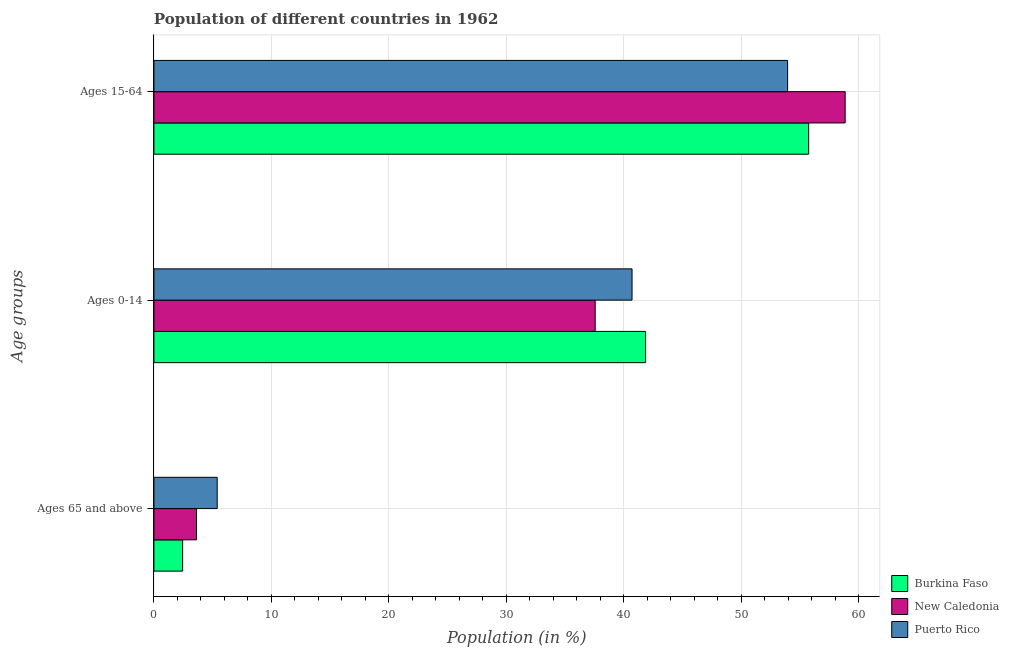How many bars are there on the 2nd tick from the top?
Offer a very short reply. 3. What is the label of the 1st group of bars from the top?
Make the answer very short. Ages 15-64. What is the percentage of population within the age-group 0-14 in New Caledonia?
Give a very brief answer. 37.55. Across all countries, what is the maximum percentage of population within the age-group 15-64?
Offer a terse response. 58.82. Across all countries, what is the minimum percentage of population within the age-group 15-64?
Give a very brief answer. 53.93. In which country was the percentage of population within the age-group 0-14 maximum?
Your response must be concise. Burkina Faso. In which country was the percentage of population within the age-group of 65 and above minimum?
Offer a terse response. Burkina Faso. What is the total percentage of population within the age-group 15-64 in the graph?
Offer a very short reply. 168.47. What is the difference between the percentage of population within the age-group 15-64 in Burkina Faso and that in New Caledonia?
Keep it short and to the point. -3.11. What is the difference between the percentage of population within the age-group 0-14 in Burkina Faso and the percentage of population within the age-group of 65 and above in Puerto Rico?
Your answer should be very brief. 36.45. What is the average percentage of population within the age-group 15-64 per country?
Give a very brief answer. 56.16. What is the difference between the percentage of population within the age-group 15-64 and percentage of population within the age-group of 65 and above in New Caledonia?
Your response must be concise. 55.2. What is the ratio of the percentage of population within the age-group of 65 and above in Puerto Rico to that in New Caledonia?
Offer a terse response. 1.49. What is the difference between the highest and the second highest percentage of population within the age-group of 65 and above?
Provide a succinct answer. 1.76. What is the difference between the highest and the lowest percentage of population within the age-group of 65 and above?
Offer a terse response. 2.94. What does the 1st bar from the top in Ages 65 and above represents?
Offer a very short reply. Puerto Rico. What does the 2nd bar from the bottom in Ages 65 and above represents?
Your answer should be very brief. New Caledonia. Is it the case that in every country, the sum of the percentage of population within the age-group of 65 and above and percentage of population within the age-group 0-14 is greater than the percentage of population within the age-group 15-64?
Offer a very short reply. No. How many countries are there in the graph?
Provide a succinct answer. 3. How many legend labels are there?
Offer a very short reply. 3. How are the legend labels stacked?
Offer a very short reply. Vertical. What is the title of the graph?
Offer a terse response. Population of different countries in 1962. What is the label or title of the Y-axis?
Provide a short and direct response. Age groups. What is the Population (in %) of Burkina Faso in Ages 65 and above?
Make the answer very short. 2.44. What is the Population (in %) in New Caledonia in Ages 65 and above?
Make the answer very short. 3.63. What is the Population (in %) of Puerto Rico in Ages 65 and above?
Provide a succinct answer. 5.39. What is the Population (in %) of Burkina Faso in Ages 0-14?
Ensure brevity in your answer.  41.84. What is the Population (in %) of New Caledonia in Ages 0-14?
Offer a very short reply. 37.55. What is the Population (in %) of Puerto Rico in Ages 0-14?
Give a very brief answer. 40.69. What is the Population (in %) of Burkina Faso in Ages 15-64?
Provide a short and direct response. 55.72. What is the Population (in %) of New Caledonia in Ages 15-64?
Your answer should be compact. 58.82. What is the Population (in %) of Puerto Rico in Ages 15-64?
Your answer should be very brief. 53.93. Across all Age groups, what is the maximum Population (in %) of Burkina Faso?
Keep it short and to the point. 55.72. Across all Age groups, what is the maximum Population (in %) in New Caledonia?
Your answer should be compact. 58.82. Across all Age groups, what is the maximum Population (in %) in Puerto Rico?
Make the answer very short. 53.93. Across all Age groups, what is the minimum Population (in %) of Burkina Faso?
Provide a succinct answer. 2.44. Across all Age groups, what is the minimum Population (in %) in New Caledonia?
Keep it short and to the point. 3.63. Across all Age groups, what is the minimum Population (in %) of Puerto Rico?
Offer a terse response. 5.39. What is the total Population (in %) of Burkina Faso in the graph?
Provide a succinct answer. 100. What is the total Population (in %) of Puerto Rico in the graph?
Your answer should be compact. 100. What is the difference between the Population (in %) in Burkina Faso in Ages 65 and above and that in Ages 0-14?
Provide a short and direct response. -39.39. What is the difference between the Population (in %) in New Caledonia in Ages 65 and above and that in Ages 0-14?
Offer a terse response. -33.93. What is the difference between the Population (in %) in Puerto Rico in Ages 65 and above and that in Ages 0-14?
Give a very brief answer. -35.3. What is the difference between the Population (in %) in Burkina Faso in Ages 65 and above and that in Ages 15-64?
Your answer should be compact. -53.28. What is the difference between the Population (in %) in New Caledonia in Ages 65 and above and that in Ages 15-64?
Offer a very short reply. -55.2. What is the difference between the Population (in %) of Puerto Rico in Ages 65 and above and that in Ages 15-64?
Offer a terse response. -48.54. What is the difference between the Population (in %) in Burkina Faso in Ages 0-14 and that in Ages 15-64?
Offer a terse response. -13.88. What is the difference between the Population (in %) in New Caledonia in Ages 0-14 and that in Ages 15-64?
Ensure brevity in your answer.  -21.27. What is the difference between the Population (in %) of Puerto Rico in Ages 0-14 and that in Ages 15-64?
Make the answer very short. -13.24. What is the difference between the Population (in %) in Burkina Faso in Ages 65 and above and the Population (in %) in New Caledonia in Ages 0-14?
Your response must be concise. -35.11. What is the difference between the Population (in %) in Burkina Faso in Ages 65 and above and the Population (in %) in Puerto Rico in Ages 0-14?
Your answer should be compact. -38.24. What is the difference between the Population (in %) in New Caledonia in Ages 65 and above and the Population (in %) in Puerto Rico in Ages 0-14?
Your response must be concise. -37.06. What is the difference between the Population (in %) in Burkina Faso in Ages 65 and above and the Population (in %) in New Caledonia in Ages 15-64?
Provide a succinct answer. -56.38. What is the difference between the Population (in %) of Burkina Faso in Ages 65 and above and the Population (in %) of Puerto Rico in Ages 15-64?
Provide a short and direct response. -51.48. What is the difference between the Population (in %) in New Caledonia in Ages 65 and above and the Population (in %) in Puerto Rico in Ages 15-64?
Offer a terse response. -50.3. What is the difference between the Population (in %) of Burkina Faso in Ages 0-14 and the Population (in %) of New Caledonia in Ages 15-64?
Offer a very short reply. -16.99. What is the difference between the Population (in %) in Burkina Faso in Ages 0-14 and the Population (in %) in Puerto Rico in Ages 15-64?
Your answer should be very brief. -12.09. What is the difference between the Population (in %) in New Caledonia in Ages 0-14 and the Population (in %) in Puerto Rico in Ages 15-64?
Your answer should be compact. -16.38. What is the average Population (in %) in Burkina Faso per Age groups?
Ensure brevity in your answer.  33.33. What is the average Population (in %) in New Caledonia per Age groups?
Your answer should be compact. 33.33. What is the average Population (in %) of Puerto Rico per Age groups?
Offer a terse response. 33.33. What is the difference between the Population (in %) in Burkina Faso and Population (in %) in New Caledonia in Ages 65 and above?
Keep it short and to the point. -1.18. What is the difference between the Population (in %) in Burkina Faso and Population (in %) in Puerto Rico in Ages 65 and above?
Offer a very short reply. -2.94. What is the difference between the Population (in %) of New Caledonia and Population (in %) of Puerto Rico in Ages 65 and above?
Provide a succinct answer. -1.76. What is the difference between the Population (in %) of Burkina Faso and Population (in %) of New Caledonia in Ages 0-14?
Provide a succinct answer. 4.29. What is the difference between the Population (in %) of Burkina Faso and Population (in %) of Puerto Rico in Ages 0-14?
Offer a very short reply. 1.15. What is the difference between the Population (in %) of New Caledonia and Population (in %) of Puerto Rico in Ages 0-14?
Make the answer very short. -3.14. What is the difference between the Population (in %) in Burkina Faso and Population (in %) in New Caledonia in Ages 15-64?
Ensure brevity in your answer.  -3.11. What is the difference between the Population (in %) in Burkina Faso and Population (in %) in Puerto Rico in Ages 15-64?
Offer a very short reply. 1.79. What is the difference between the Population (in %) of New Caledonia and Population (in %) of Puerto Rico in Ages 15-64?
Keep it short and to the point. 4.9. What is the ratio of the Population (in %) of Burkina Faso in Ages 65 and above to that in Ages 0-14?
Your answer should be compact. 0.06. What is the ratio of the Population (in %) in New Caledonia in Ages 65 and above to that in Ages 0-14?
Your answer should be very brief. 0.1. What is the ratio of the Population (in %) of Puerto Rico in Ages 65 and above to that in Ages 0-14?
Give a very brief answer. 0.13. What is the ratio of the Population (in %) of Burkina Faso in Ages 65 and above to that in Ages 15-64?
Your answer should be compact. 0.04. What is the ratio of the Population (in %) of New Caledonia in Ages 65 and above to that in Ages 15-64?
Provide a short and direct response. 0.06. What is the ratio of the Population (in %) of Puerto Rico in Ages 65 and above to that in Ages 15-64?
Offer a very short reply. 0.1. What is the ratio of the Population (in %) in Burkina Faso in Ages 0-14 to that in Ages 15-64?
Make the answer very short. 0.75. What is the ratio of the Population (in %) of New Caledonia in Ages 0-14 to that in Ages 15-64?
Offer a terse response. 0.64. What is the ratio of the Population (in %) of Puerto Rico in Ages 0-14 to that in Ages 15-64?
Offer a terse response. 0.75. What is the difference between the highest and the second highest Population (in %) in Burkina Faso?
Give a very brief answer. 13.88. What is the difference between the highest and the second highest Population (in %) of New Caledonia?
Make the answer very short. 21.27. What is the difference between the highest and the second highest Population (in %) of Puerto Rico?
Provide a short and direct response. 13.24. What is the difference between the highest and the lowest Population (in %) of Burkina Faso?
Your response must be concise. 53.28. What is the difference between the highest and the lowest Population (in %) of New Caledonia?
Your response must be concise. 55.2. What is the difference between the highest and the lowest Population (in %) in Puerto Rico?
Ensure brevity in your answer.  48.54. 